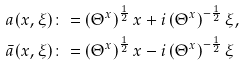Convert formula to latex. <formula><loc_0><loc_0><loc_500><loc_500>a ( x , \xi ) & \colon = \left ( \Theta ^ { x } \right ) ^ { \frac { 1 } { 2 } } x + i \left ( \Theta ^ { x } \right ) ^ { - \frac { 1 } { 2 } } \xi , \\ \bar { a } ( x , \xi ) & \colon = \left ( \Theta ^ { x } \right ) ^ { \frac { 1 } { 2 } } x - i \left ( \Theta ^ { x } \right ) ^ { - \frac { 1 } { 2 } } \xi</formula> 